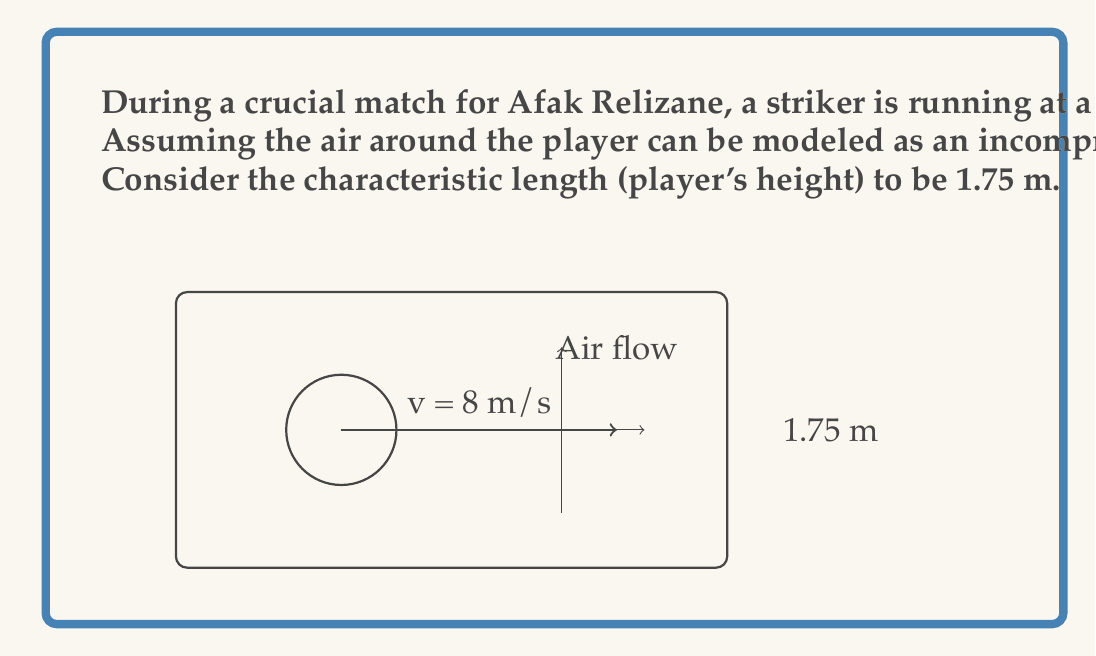Show me your answer to this math problem. To solve this problem, we need to calculate the Reynolds number using the Navier-Stokes equations for incompressible flow. The Reynolds number is a dimensionless quantity that helps predict flow patterns in different fluid flow situations.

The Reynolds number is given by the formula:

$$ Re = \frac{\rho v L}{\mu} $$

Where:
- $\rho$ is the density of the fluid (air in this case)
- $v$ is the velocity of the fluid relative to the object (player's velocity)
- $L$ is the characteristic length (player's height)
- $\mu$ is the dynamic viscosity of the fluid

Given:
- $\rho = 1.225 \text{ kg/m³}$
- $v = 8 \text{ m/s}$
- $L = 1.75 \text{ m}$
- $\mu = 1.81 \times 10^{-5} \text{ kg/(m·s)}$

Let's substitute these values into the Reynolds number equation:

$$ Re = \frac{(1.225 \text{ kg/m³}) \times (8 \text{ m/s}) \times (1.75 \text{ m})}{1.81 \times 10^{-5} \text{ kg/(m·s)}} $$

Simplifying:

$$ Re = \frac{17.15}{1.81 \times 10^{-5}} = 947514.7 $$

Rounding to the nearest whole number:

$$ Re \approx 947515 $$

This high Reynolds number indicates that the airflow around the Afak Relizane striker is turbulent, which is typical for airflow around athletes in motion.
Answer: 947515 